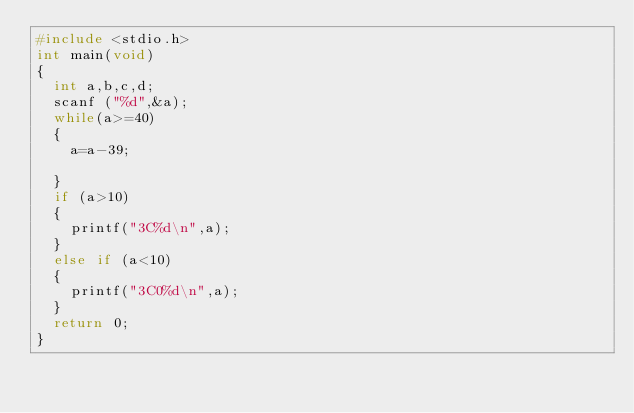<code> <loc_0><loc_0><loc_500><loc_500><_C_>#include <stdio.h>
int main(void)
{
	int a,b,c,d;
	scanf ("%d",&a);
	while(a>=40)
	{
		a=a-39;
		
	}
	if (a>10)
	{
		printf("3C%d\n",a);
	}
	else if (a<10)
	{
		printf("3C0%d\n",a);
	}
	return 0;
}</code> 